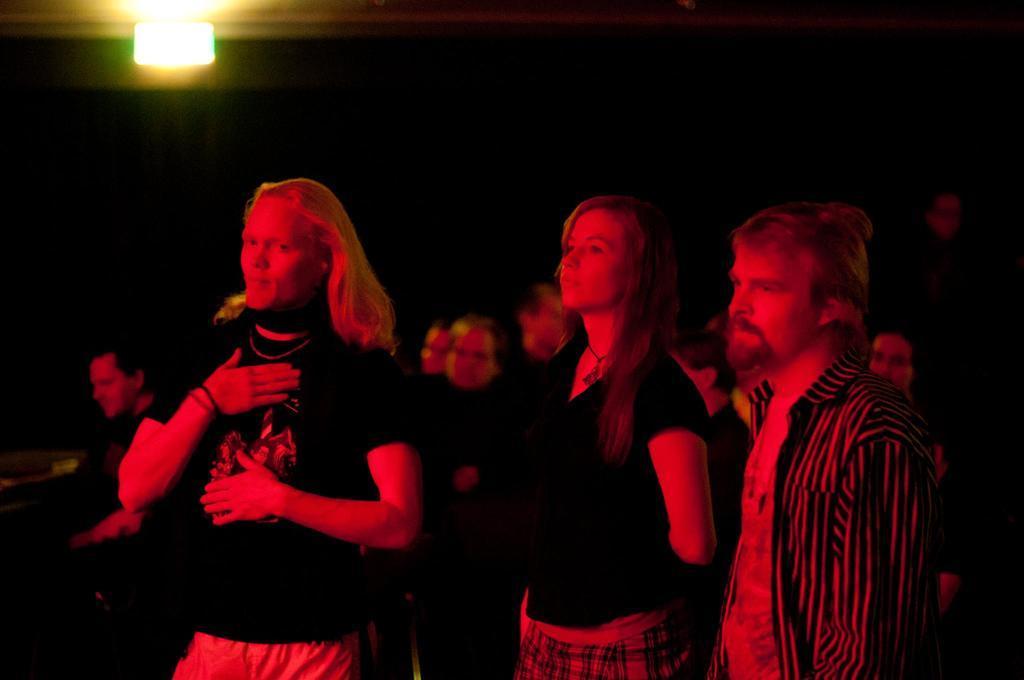Can you describe this image briefly? This is an image clicked in the dark. Here I can see few people are standing facing towards the left side. On the top there is a light. 